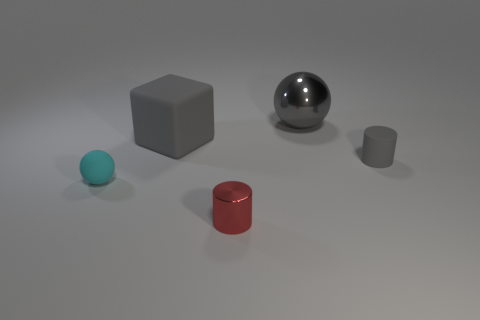Is there anything else that has the same color as the metal cylinder?
Your response must be concise. No. Are there any tiny red objects that are in front of the metallic thing left of the big object that is on the right side of the red metallic cylinder?
Keep it short and to the point. No. Does the matte object to the right of the large gray cube have the same color as the big metal ball?
Your answer should be compact. Yes. What number of cylinders are cyan things or large green matte things?
Keep it short and to the point. 0. There is a shiny thing that is in front of the small rubber thing that is in front of the tiny gray matte cylinder; what shape is it?
Make the answer very short. Cylinder. What is the size of the ball that is in front of the thing behind the large gray thing in front of the gray metallic ball?
Make the answer very short. Small. Do the gray cylinder and the gray shiny sphere have the same size?
Your answer should be very brief. No. What number of things are either big purple shiny spheres or large blocks?
Provide a succinct answer. 1. What is the size of the shiny object that is on the right side of the thing in front of the tiny rubber sphere?
Your response must be concise. Large. The gray matte cylinder has what size?
Provide a short and direct response. Small. 